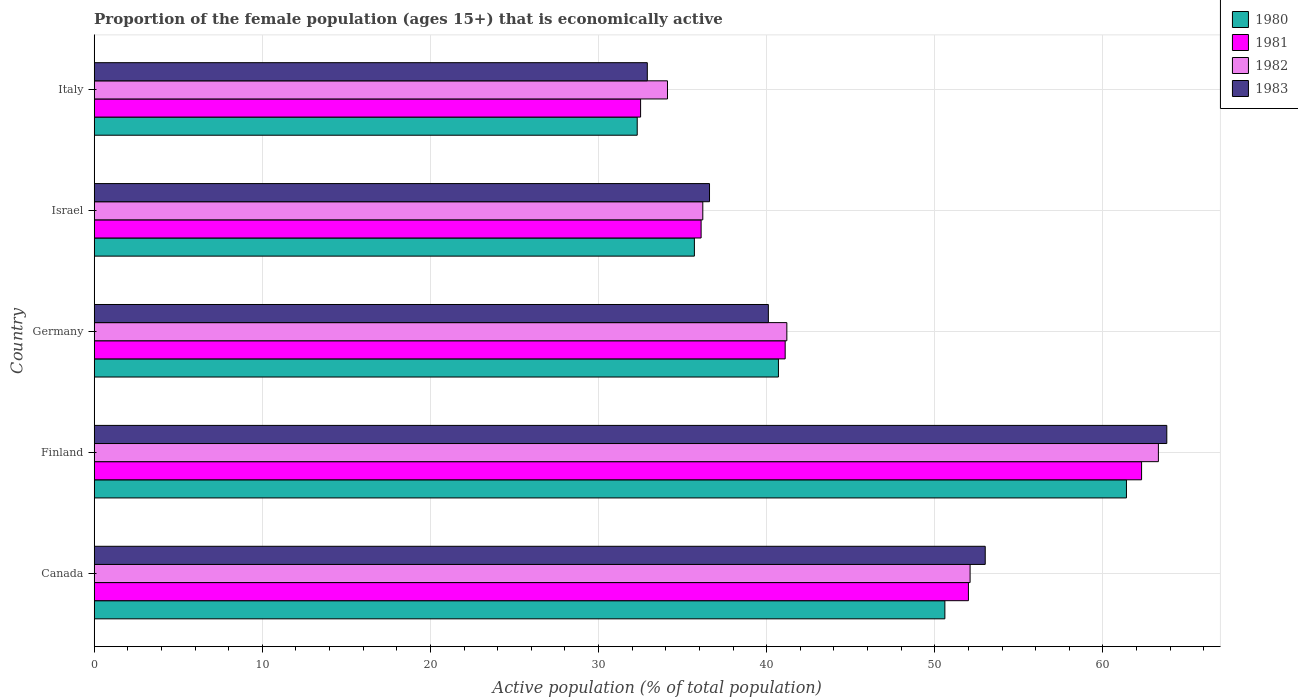How many different coloured bars are there?
Provide a succinct answer. 4. Are the number of bars per tick equal to the number of legend labels?
Give a very brief answer. Yes. Are the number of bars on each tick of the Y-axis equal?
Provide a succinct answer. Yes. How many bars are there on the 3rd tick from the top?
Your answer should be very brief. 4. How many bars are there on the 3rd tick from the bottom?
Make the answer very short. 4. What is the label of the 4th group of bars from the top?
Keep it short and to the point. Finland. What is the proportion of the female population that is economically active in 1982 in Finland?
Provide a succinct answer. 63.3. Across all countries, what is the maximum proportion of the female population that is economically active in 1981?
Keep it short and to the point. 62.3. Across all countries, what is the minimum proportion of the female population that is economically active in 1982?
Your answer should be compact. 34.1. What is the total proportion of the female population that is economically active in 1981 in the graph?
Provide a succinct answer. 224. What is the difference between the proportion of the female population that is economically active in 1980 in Canada and that in Israel?
Provide a succinct answer. 14.9. What is the difference between the proportion of the female population that is economically active in 1981 in Italy and the proportion of the female population that is economically active in 1983 in Germany?
Ensure brevity in your answer.  -7.6. What is the average proportion of the female population that is economically active in 1983 per country?
Your response must be concise. 45.28. What is the ratio of the proportion of the female population that is economically active in 1982 in Canada to that in Italy?
Ensure brevity in your answer.  1.53. What is the difference between the highest and the second highest proportion of the female population that is economically active in 1982?
Your response must be concise. 11.2. What is the difference between the highest and the lowest proportion of the female population that is economically active in 1982?
Offer a terse response. 29.2. In how many countries, is the proportion of the female population that is economically active in 1980 greater than the average proportion of the female population that is economically active in 1980 taken over all countries?
Give a very brief answer. 2. Is it the case that in every country, the sum of the proportion of the female population that is economically active in 1983 and proportion of the female population that is economically active in 1981 is greater than the sum of proportion of the female population that is economically active in 1982 and proportion of the female population that is economically active in 1980?
Keep it short and to the point. No. Is it the case that in every country, the sum of the proportion of the female population that is economically active in 1983 and proportion of the female population that is economically active in 1982 is greater than the proportion of the female population that is economically active in 1980?
Provide a succinct answer. Yes. How many bars are there?
Provide a short and direct response. 20. How many countries are there in the graph?
Provide a short and direct response. 5. What is the difference between two consecutive major ticks on the X-axis?
Ensure brevity in your answer.  10. What is the title of the graph?
Provide a succinct answer. Proportion of the female population (ages 15+) that is economically active. What is the label or title of the X-axis?
Your answer should be compact. Active population (% of total population). What is the label or title of the Y-axis?
Offer a very short reply. Country. What is the Active population (% of total population) of 1980 in Canada?
Your response must be concise. 50.6. What is the Active population (% of total population) of 1982 in Canada?
Your answer should be compact. 52.1. What is the Active population (% of total population) in 1983 in Canada?
Make the answer very short. 53. What is the Active population (% of total population) in 1980 in Finland?
Offer a terse response. 61.4. What is the Active population (% of total population) in 1981 in Finland?
Your answer should be very brief. 62.3. What is the Active population (% of total population) in 1982 in Finland?
Provide a succinct answer. 63.3. What is the Active population (% of total population) of 1983 in Finland?
Provide a short and direct response. 63.8. What is the Active population (% of total population) in 1980 in Germany?
Provide a succinct answer. 40.7. What is the Active population (% of total population) of 1981 in Germany?
Give a very brief answer. 41.1. What is the Active population (% of total population) in 1982 in Germany?
Offer a very short reply. 41.2. What is the Active population (% of total population) of 1983 in Germany?
Keep it short and to the point. 40.1. What is the Active population (% of total population) in 1980 in Israel?
Your answer should be compact. 35.7. What is the Active population (% of total population) of 1981 in Israel?
Ensure brevity in your answer.  36.1. What is the Active population (% of total population) in 1982 in Israel?
Make the answer very short. 36.2. What is the Active population (% of total population) of 1983 in Israel?
Provide a short and direct response. 36.6. What is the Active population (% of total population) in 1980 in Italy?
Offer a terse response. 32.3. What is the Active population (% of total population) in 1981 in Italy?
Give a very brief answer. 32.5. What is the Active population (% of total population) in 1982 in Italy?
Offer a terse response. 34.1. What is the Active population (% of total population) in 1983 in Italy?
Your answer should be compact. 32.9. Across all countries, what is the maximum Active population (% of total population) in 1980?
Keep it short and to the point. 61.4. Across all countries, what is the maximum Active population (% of total population) of 1981?
Provide a succinct answer. 62.3. Across all countries, what is the maximum Active population (% of total population) of 1982?
Keep it short and to the point. 63.3. Across all countries, what is the maximum Active population (% of total population) of 1983?
Offer a very short reply. 63.8. Across all countries, what is the minimum Active population (% of total population) of 1980?
Keep it short and to the point. 32.3. Across all countries, what is the minimum Active population (% of total population) of 1981?
Keep it short and to the point. 32.5. Across all countries, what is the minimum Active population (% of total population) in 1982?
Make the answer very short. 34.1. Across all countries, what is the minimum Active population (% of total population) of 1983?
Offer a terse response. 32.9. What is the total Active population (% of total population) in 1980 in the graph?
Give a very brief answer. 220.7. What is the total Active population (% of total population) of 1981 in the graph?
Ensure brevity in your answer.  224. What is the total Active population (% of total population) in 1982 in the graph?
Your answer should be compact. 226.9. What is the total Active population (% of total population) of 1983 in the graph?
Offer a terse response. 226.4. What is the difference between the Active population (% of total population) of 1982 in Canada and that in Finland?
Give a very brief answer. -11.2. What is the difference between the Active population (% of total population) of 1983 in Canada and that in Finland?
Your answer should be compact. -10.8. What is the difference between the Active population (% of total population) of 1980 in Canada and that in Germany?
Offer a terse response. 9.9. What is the difference between the Active population (% of total population) of 1983 in Canada and that in Germany?
Provide a succinct answer. 12.9. What is the difference between the Active population (% of total population) of 1981 in Canada and that in Israel?
Give a very brief answer. 15.9. What is the difference between the Active population (% of total population) in 1983 in Canada and that in Israel?
Your response must be concise. 16.4. What is the difference between the Active population (% of total population) of 1981 in Canada and that in Italy?
Ensure brevity in your answer.  19.5. What is the difference between the Active population (% of total population) in 1983 in Canada and that in Italy?
Your response must be concise. 20.1. What is the difference between the Active population (% of total population) in 1980 in Finland and that in Germany?
Give a very brief answer. 20.7. What is the difference between the Active population (% of total population) of 1981 in Finland and that in Germany?
Offer a terse response. 21.2. What is the difference between the Active population (% of total population) in 1982 in Finland and that in Germany?
Offer a terse response. 22.1. What is the difference between the Active population (% of total population) in 1983 in Finland and that in Germany?
Provide a short and direct response. 23.7. What is the difference between the Active population (% of total population) of 1980 in Finland and that in Israel?
Offer a terse response. 25.7. What is the difference between the Active population (% of total population) in 1981 in Finland and that in Israel?
Give a very brief answer. 26.2. What is the difference between the Active population (% of total population) in 1982 in Finland and that in Israel?
Your answer should be compact. 27.1. What is the difference between the Active population (% of total population) of 1983 in Finland and that in Israel?
Provide a short and direct response. 27.2. What is the difference between the Active population (% of total population) of 1980 in Finland and that in Italy?
Make the answer very short. 29.1. What is the difference between the Active population (% of total population) of 1981 in Finland and that in Italy?
Provide a succinct answer. 29.8. What is the difference between the Active population (% of total population) in 1982 in Finland and that in Italy?
Give a very brief answer. 29.2. What is the difference between the Active population (% of total population) in 1983 in Finland and that in Italy?
Keep it short and to the point. 30.9. What is the difference between the Active population (% of total population) in 1981 in Germany and that in Israel?
Keep it short and to the point. 5. What is the difference between the Active population (% of total population) of 1982 in Germany and that in Israel?
Your answer should be very brief. 5. What is the difference between the Active population (% of total population) of 1981 in Germany and that in Italy?
Ensure brevity in your answer.  8.6. What is the difference between the Active population (% of total population) of 1983 in Germany and that in Italy?
Give a very brief answer. 7.2. What is the difference between the Active population (% of total population) in 1980 in Israel and that in Italy?
Provide a short and direct response. 3.4. What is the difference between the Active population (% of total population) of 1983 in Israel and that in Italy?
Your response must be concise. 3.7. What is the difference between the Active population (% of total population) of 1980 in Canada and the Active population (% of total population) of 1982 in Finland?
Provide a short and direct response. -12.7. What is the difference between the Active population (% of total population) in 1981 in Canada and the Active population (% of total population) in 1983 in Finland?
Give a very brief answer. -11.8. What is the difference between the Active population (% of total population) of 1982 in Canada and the Active population (% of total population) of 1983 in Finland?
Your response must be concise. -11.7. What is the difference between the Active population (% of total population) of 1980 in Canada and the Active population (% of total population) of 1981 in Germany?
Offer a terse response. 9.5. What is the difference between the Active population (% of total population) of 1980 in Canada and the Active population (% of total population) of 1983 in Germany?
Your answer should be compact. 10.5. What is the difference between the Active population (% of total population) of 1981 in Canada and the Active population (% of total population) of 1982 in Germany?
Provide a succinct answer. 10.8. What is the difference between the Active population (% of total population) of 1981 in Canada and the Active population (% of total population) of 1983 in Germany?
Make the answer very short. 11.9. What is the difference between the Active population (% of total population) in 1980 in Canada and the Active population (% of total population) in 1981 in Israel?
Your answer should be compact. 14.5. What is the difference between the Active population (% of total population) of 1980 in Canada and the Active population (% of total population) of 1982 in Israel?
Ensure brevity in your answer.  14.4. What is the difference between the Active population (% of total population) in 1980 in Canada and the Active population (% of total population) in 1983 in Israel?
Your answer should be very brief. 14. What is the difference between the Active population (% of total population) in 1981 in Canada and the Active population (% of total population) in 1983 in Israel?
Provide a succinct answer. 15.4. What is the difference between the Active population (% of total population) in 1982 in Canada and the Active population (% of total population) in 1983 in Israel?
Your response must be concise. 15.5. What is the difference between the Active population (% of total population) in 1980 in Canada and the Active population (% of total population) in 1981 in Italy?
Offer a terse response. 18.1. What is the difference between the Active population (% of total population) of 1980 in Canada and the Active population (% of total population) of 1983 in Italy?
Keep it short and to the point. 17.7. What is the difference between the Active population (% of total population) in 1982 in Canada and the Active population (% of total population) in 1983 in Italy?
Provide a short and direct response. 19.2. What is the difference between the Active population (% of total population) of 1980 in Finland and the Active population (% of total population) of 1981 in Germany?
Offer a terse response. 20.3. What is the difference between the Active population (% of total population) in 1980 in Finland and the Active population (% of total population) in 1982 in Germany?
Your answer should be very brief. 20.2. What is the difference between the Active population (% of total population) in 1980 in Finland and the Active population (% of total population) in 1983 in Germany?
Your answer should be compact. 21.3. What is the difference between the Active population (% of total population) in 1981 in Finland and the Active population (% of total population) in 1982 in Germany?
Offer a terse response. 21.1. What is the difference between the Active population (% of total population) of 1982 in Finland and the Active population (% of total population) of 1983 in Germany?
Your answer should be compact. 23.2. What is the difference between the Active population (% of total population) in 1980 in Finland and the Active population (% of total population) in 1981 in Israel?
Your answer should be compact. 25.3. What is the difference between the Active population (% of total population) of 1980 in Finland and the Active population (% of total population) of 1982 in Israel?
Offer a terse response. 25.2. What is the difference between the Active population (% of total population) in 1980 in Finland and the Active population (% of total population) in 1983 in Israel?
Your answer should be compact. 24.8. What is the difference between the Active population (% of total population) of 1981 in Finland and the Active population (% of total population) of 1982 in Israel?
Provide a succinct answer. 26.1. What is the difference between the Active population (% of total population) in 1981 in Finland and the Active population (% of total population) in 1983 in Israel?
Your response must be concise. 25.7. What is the difference between the Active population (% of total population) of 1982 in Finland and the Active population (% of total population) of 1983 in Israel?
Your response must be concise. 26.7. What is the difference between the Active population (% of total population) of 1980 in Finland and the Active population (% of total population) of 1981 in Italy?
Your answer should be very brief. 28.9. What is the difference between the Active population (% of total population) in 1980 in Finland and the Active population (% of total population) in 1982 in Italy?
Give a very brief answer. 27.3. What is the difference between the Active population (% of total population) in 1981 in Finland and the Active population (% of total population) in 1982 in Italy?
Offer a terse response. 28.2. What is the difference between the Active population (% of total population) in 1981 in Finland and the Active population (% of total population) in 1983 in Italy?
Ensure brevity in your answer.  29.4. What is the difference between the Active population (% of total population) in 1982 in Finland and the Active population (% of total population) in 1983 in Italy?
Offer a very short reply. 30.4. What is the difference between the Active population (% of total population) in 1980 in Germany and the Active population (% of total population) in 1982 in Israel?
Your answer should be very brief. 4.5. What is the difference between the Active population (% of total population) in 1980 in Germany and the Active population (% of total population) in 1983 in Israel?
Offer a very short reply. 4.1. What is the difference between the Active population (% of total population) in 1981 in Germany and the Active population (% of total population) in 1982 in Israel?
Give a very brief answer. 4.9. What is the difference between the Active population (% of total population) in 1981 in Germany and the Active population (% of total population) in 1983 in Israel?
Give a very brief answer. 4.5. What is the difference between the Active population (% of total population) in 1982 in Germany and the Active population (% of total population) in 1983 in Israel?
Make the answer very short. 4.6. What is the difference between the Active population (% of total population) in 1980 in Germany and the Active population (% of total population) in 1981 in Italy?
Your answer should be compact. 8.2. What is the difference between the Active population (% of total population) of 1980 in Germany and the Active population (% of total population) of 1982 in Italy?
Your response must be concise. 6.6. What is the difference between the Active population (% of total population) of 1980 in Germany and the Active population (% of total population) of 1983 in Italy?
Provide a short and direct response. 7.8. What is the difference between the Active population (% of total population) of 1981 in Germany and the Active population (% of total population) of 1982 in Italy?
Offer a terse response. 7. What is the difference between the Active population (% of total population) in 1982 in Germany and the Active population (% of total population) in 1983 in Italy?
Make the answer very short. 8.3. What is the difference between the Active population (% of total population) of 1981 in Israel and the Active population (% of total population) of 1982 in Italy?
Provide a short and direct response. 2. What is the difference between the Active population (% of total population) of 1982 in Israel and the Active population (% of total population) of 1983 in Italy?
Provide a succinct answer. 3.3. What is the average Active population (% of total population) of 1980 per country?
Offer a terse response. 44.14. What is the average Active population (% of total population) in 1981 per country?
Offer a very short reply. 44.8. What is the average Active population (% of total population) in 1982 per country?
Provide a succinct answer. 45.38. What is the average Active population (% of total population) of 1983 per country?
Offer a terse response. 45.28. What is the difference between the Active population (% of total population) of 1981 and Active population (% of total population) of 1982 in Canada?
Your answer should be very brief. -0.1. What is the difference between the Active population (% of total population) of 1981 and Active population (% of total population) of 1983 in Canada?
Your answer should be very brief. -1. What is the difference between the Active population (% of total population) in 1980 and Active population (% of total population) in 1983 in Finland?
Your answer should be very brief. -2.4. What is the difference between the Active population (% of total population) of 1981 and Active population (% of total population) of 1983 in Finland?
Your answer should be very brief. -1.5. What is the difference between the Active population (% of total population) in 1982 and Active population (% of total population) in 1983 in Finland?
Give a very brief answer. -0.5. What is the difference between the Active population (% of total population) in 1980 and Active population (% of total population) in 1983 in Germany?
Ensure brevity in your answer.  0.6. What is the difference between the Active population (% of total population) in 1981 and Active population (% of total population) in 1982 in Germany?
Your answer should be very brief. -0.1. What is the difference between the Active population (% of total population) in 1981 and Active population (% of total population) in 1983 in Germany?
Offer a very short reply. 1. What is the difference between the Active population (% of total population) of 1982 and Active population (% of total population) of 1983 in Germany?
Your answer should be compact. 1.1. What is the difference between the Active population (% of total population) of 1980 and Active population (% of total population) of 1981 in Israel?
Keep it short and to the point. -0.4. What is the difference between the Active population (% of total population) in 1980 and Active population (% of total population) in 1982 in Israel?
Your answer should be very brief. -0.5. What is the difference between the Active population (% of total population) of 1980 and Active population (% of total population) of 1983 in Israel?
Your answer should be compact. -0.9. What is the difference between the Active population (% of total population) in 1981 and Active population (% of total population) in 1983 in Israel?
Your answer should be very brief. -0.5. What is the difference between the Active population (% of total population) in 1982 and Active population (% of total population) in 1983 in Israel?
Provide a succinct answer. -0.4. What is the difference between the Active population (% of total population) in 1980 and Active population (% of total population) in 1982 in Italy?
Your response must be concise. -1.8. What is the difference between the Active population (% of total population) of 1982 and Active population (% of total population) of 1983 in Italy?
Ensure brevity in your answer.  1.2. What is the ratio of the Active population (% of total population) of 1980 in Canada to that in Finland?
Your answer should be very brief. 0.82. What is the ratio of the Active population (% of total population) in 1981 in Canada to that in Finland?
Your response must be concise. 0.83. What is the ratio of the Active population (% of total population) of 1982 in Canada to that in Finland?
Provide a succinct answer. 0.82. What is the ratio of the Active population (% of total population) of 1983 in Canada to that in Finland?
Your response must be concise. 0.83. What is the ratio of the Active population (% of total population) of 1980 in Canada to that in Germany?
Your answer should be very brief. 1.24. What is the ratio of the Active population (% of total population) of 1981 in Canada to that in Germany?
Offer a very short reply. 1.27. What is the ratio of the Active population (% of total population) of 1982 in Canada to that in Germany?
Your answer should be very brief. 1.26. What is the ratio of the Active population (% of total population) in 1983 in Canada to that in Germany?
Provide a short and direct response. 1.32. What is the ratio of the Active population (% of total population) of 1980 in Canada to that in Israel?
Keep it short and to the point. 1.42. What is the ratio of the Active population (% of total population) in 1981 in Canada to that in Israel?
Your response must be concise. 1.44. What is the ratio of the Active population (% of total population) of 1982 in Canada to that in Israel?
Ensure brevity in your answer.  1.44. What is the ratio of the Active population (% of total population) in 1983 in Canada to that in Israel?
Offer a very short reply. 1.45. What is the ratio of the Active population (% of total population) in 1980 in Canada to that in Italy?
Your answer should be very brief. 1.57. What is the ratio of the Active population (% of total population) in 1982 in Canada to that in Italy?
Provide a short and direct response. 1.53. What is the ratio of the Active population (% of total population) in 1983 in Canada to that in Italy?
Make the answer very short. 1.61. What is the ratio of the Active population (% of total population) in 1980 in Finland to that in Germany?
Your answer should be compact. 1.51. What is the ratio of the Active population (% of total population) in 1981 in Finland to that in Germany?
Ensure brevity in your answer.  1.52. What is the ratio of the Active population (% of total population) in 1982 in Finland to that in Germany?
Give a very brief answer. 1.54. What is the ratio of the Active population (% of total population) in 1983 in Finland to that in Germany?
Offer a terse response. 1.59. What is the ratio of the Active population (% of total population) in 1980 in Finland to that in Israel?
Give a very brief answer. 1.72. What is the ratio of the Active population (% of total population) in 1981 in Finland to that in Israel?
Your response must be concise. 1.73. What is the ratio of the Active population (% of total population) in 1982 in Finland to that in Israel?
Provide a short and direct response. 1.75. What is the ratio of the Active population (% of total population) of 1983 in Finland to that in Israel?
Make the answer very short. 1.74. What is the ratio of the Active population (% of total population) in 1980 in Finland to that in Italy?
Ensure brevity in your answer.  1.9. What is the ratio of the Active population (% of total population) of 1981 in Finland to that in Italy?
Provide a succinct answer. 1.92. What is the ratio of the Active population (% of total population) of 1982 in Finland to that in Italy?
Your response must be concise. 1.86. What is the ratio of the Active population (% of total population) of 1983 in Finland to that in Italy?
Offer a terse response. 1.94. What is the ratio of the Active population (% of total population) of 1980 in Germany to that in Israel?
Keep it short and to the point. 1.14. What is the ratio of the Active population (% of total population) of 1981 in Germany to that in Israel?
Provide a succinct answer. 1.14. What is the ratio of the Active population (% of total population) of 1982 in Germany to that in Israel?
Offer a terse response. 1.14. What is the ratio of the Active population (% of total population) of 1983 in Germany to that in Israel?
Your answer should be compact. 1.1. What is the ratio of the Active population (% of total population) of 1980 in Germany to that in Italy?
Offer a very short reply. 1.26. What is the ratio of the Active population (% of total population) of 1981 in Germany to that in Italy?
Give a very brief answer. 1.26. What is the ratio of the Active population (% of total population) of 1982 in Germany to that in Italy?
Make the answer very short. 1.21. What is the ratio of the Active population (% of total population) of 1983 in Germany to that in Italy?
Give a very brief answer. 1.22. What is the ratio of the Active population (% of total population) in 1980 in Israel to that in Italy?
Offer a terse response. 1.11. What is the ratio of the Active population (% of total population) of 1981 in Israel to that in Italy?
Your answer should be very brief. 1.11. What is the ratio of the Active population (% of total population) in 1982 in Israel to that in Italy?
Ensure brevity in your answer.  1.06. What is the ratio of the Active population (% of total population) of 1983 in Israel to that in Italy?
Make the answer very short. 1.11. What is the difference between the highest and the second highest Active population (% of total population) in 1980?
Provide a succinct answer. 10.8. What is the difference between the highest and the lowest Active population (% of total population) of 1980?
Give a very brief answer. 29.1. What is the difference between the highest and the lowest Active population (% of total population) in 1981?
Your response must be concise. 29.8. What is the difference between the highest and the lowest Active population (% of total population) of 1982?
Provide a succinct answer. 29.2. What is the difference between the highest and the lowest Active population (% of total population) in 1983?
Your response must be concise. 30.9. 